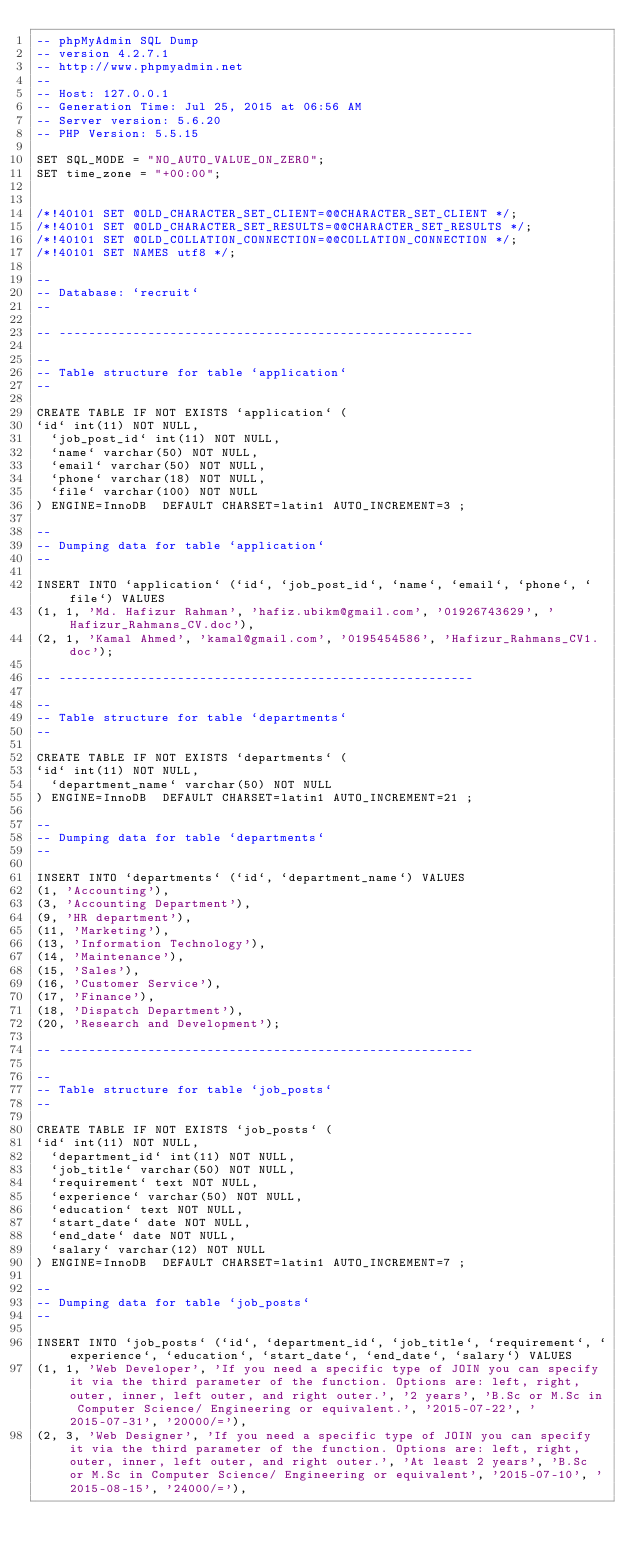Convert code to text. <code><loc_0><loc_0><loc_500><loc_500><_SQL_>-- phpMyAdmin SQL Dump
-- version 4.2.7.1
-- http://www.phpmyadmin.net
--
-- Host: 127.0.0.1
-- Generation Time: Jul 25, 2015 at 06:56 AM
-- Server version: 5.6.20
-- PHP Version: 5.5.15

SET SQL_MODE = "NO_AUTO_VALUE_ON_ZERO";
SET time_zone = "+00:00";


/*!40101 SET @OLD_CHARACTER_SET_CLIENT=@@CHARACTER_SET_CLIENT */;
/*!40101 SET @OLD_CHARACTER_SET_RESULTS=@@CHARACTER_SET_RESULTS */;
/*!40101 SET @OLD_COLLATION_CONNECTION=@@COLLATION_CONNECTION */;
/*!40101 SET NAMES utf8 */;

--
-- Database: `recruit`
--

-- --------------------------------------------------------

--
-- Table structure for table `application`
--

CREATE TABLE IF NOT EXISTS `application` (
`id` int(11) NOT NULL,
  `job_post_id` int(11) NOT NULL,
  `name` varchar(50) NOT NULL,
  `email` varchar(50) NOT NULL,
  `phone` varchar(18) NOT NULL,
  `file` varchar(100) NOT NULL
) ENGINE=InnoDB  DEFAULT CHARSET=latin1 AUTO_INCREMENT=3 ;

--
-- Dumping data for table `application`
--

INSERT INTO `application` (`id`, `job_post_id`, `name`, `email`, `phone`, `file`) VALUES
(1, 1, 'Md. Hafizur Rahman', 'hafiz.ubikm@gmail.com', '01926743629', 'Hafizur_Rahmans_CV.doc'),
(2, 1, 'Kamal Ahmed', 'kamal@gmail.com', '0195454586', 'Hafizur_Rahmans_CV1.doc');

-- --------------------------------------------------------

--
-- Table structure for table `departments`
--

CREATE TABLE IF NOT EXISTS `departments` (
`id` int(11) NOT NULL,
  `department_name` varchar(50) NOT NULL
) ENGINE=InnoDB  DEFAULT CHARSET=latin1 AUTO_INCREMENT=21 ;

--
-- Dumping data for table `departments`
--

INSERT INTO `departments` (`id`, `department_name`) VALUES
(1, 'Accounting'),
(3, 'Accounting Department'),
(9, 'HR department'),
(11, 'Marketing'),
(13, 'Information Technology'),
(14, 'Maintenance'),
(15, 'Sales'),
(16, 'Customer Service'),
(17, 'Finance'),
(18, 'Dispatch Department'),
(20, 'Research and Development');

-- --------------------------------------------------------

--
-- Table structure for table `job_posts`
--

CREATE TABLE IF NOT EXISTS `job_posts` (
`id` int(11) NOT NULL,
  `department_id` int(11) NOT NULL,
  `job_title` varchar(50) NOT NULL,
  `requirement` text NOT NULL,
  `experience` varchar(50) NOT NULL,
  `education` text NOT NULL,
  `start_date` date NOT NULL,
  `end_date` date NOT NULL,
  `salary` varchar(12) NOT NULL
) ENGINE=InnoDB  DEFAULT CHARSET=latin1 AUTO_INCREMENT=7 ;

--
-- Dumping data for table `job_posts`
--

INSERT INTO `job_posts` (`id`, `department_id`, `job_title`, `requirement`, `experience`, `education`, `start_date`, `end_date`, `salary`) VALUES
(1, 1, 'Web Developer', 'If you need a specific type of JOIN you can specify it via the third parameter of the function. Options are: left, right, outer, inner, left outer, and right outer.', '2 years', 'B.Sc or M.Sc in Computer Science/ Engineering or equivalent.', '2015-07-22', '2015-07-31', '20000/='),
(2, 3, 'Web Designer', 'If you need a specific type of JOIN you can specify it via the third parameter of the function. Options are: left, right, outer, inner, left outer, and right outer.', 'At least 2 years', 'B.Sc or M.Sc in Computer Science/ Engineering or equivalent', '2015-07-10', '2015-08-15', '24000/='),</code> 